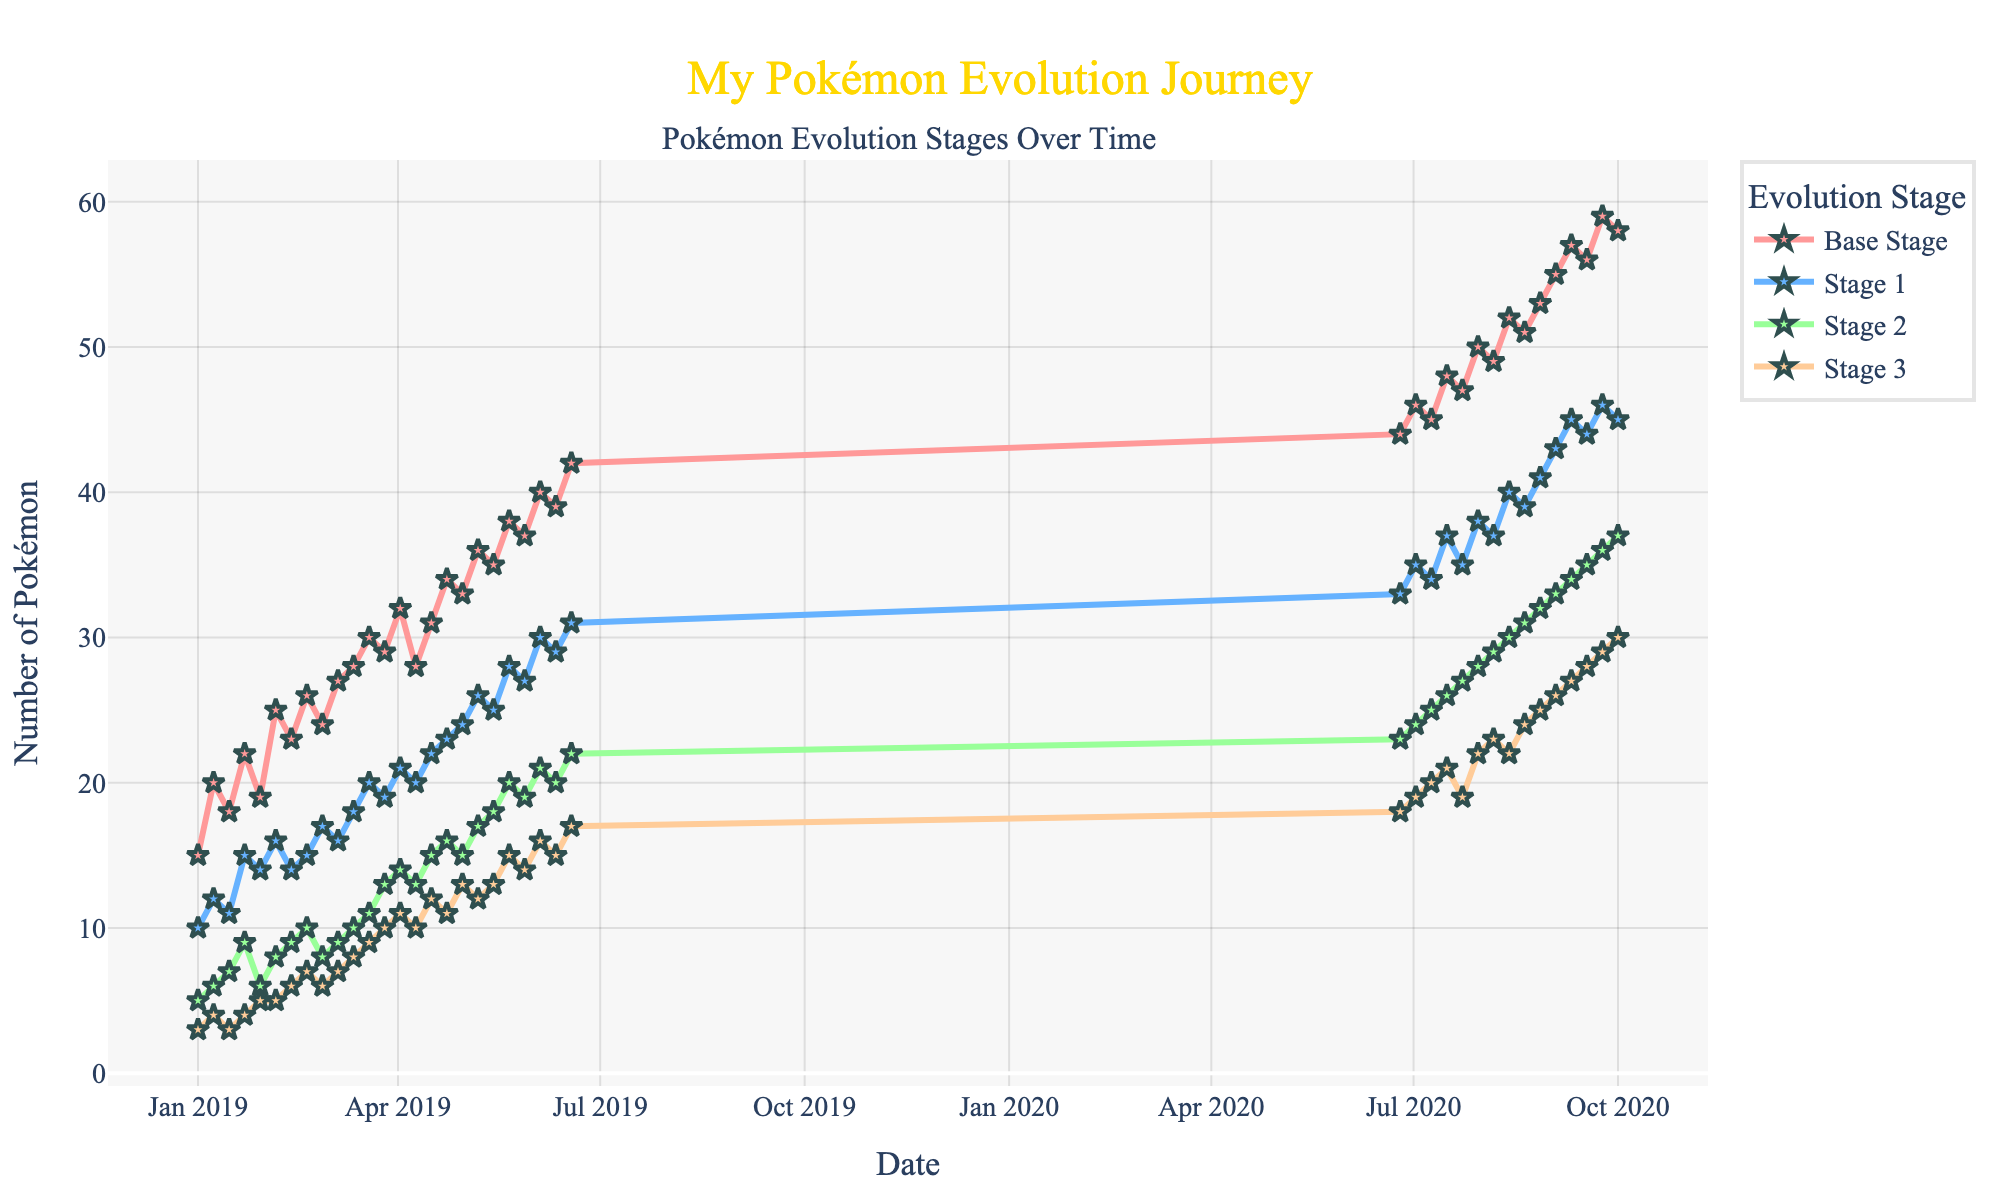What's the title of the figure? The title is located at the top of the figure and is displayed prominently in a larger font and often in a different style or color compared to other text in the figure.
Answer: My Pokémon Evolution Journey How many evolution stages are tracked in the figure? The figure uses different colored lines and markers to represent each evolution stage.
Answer: Four Which evolution stage had the highest count on July 16, 2020? The data points along the x-axis represent dates, and by locating July 16, 2020, and looking at the heights of the markers for each stage, one can determine which stage had the highest count.
Answer: Base Stage In which period did the number of Base Stage Pokémon consistently increase? By examining the line representing the Base Stage and identifying intervals where the slope is consistently upward, you can pinpoint such a period.
Answer: January to October 2020 Which evolution stage showed the smallest variation in count? Variation in count can be observed through the differences between the lowest and highest points of each line. The line with the least fluctuation indicates the smallest variation.
Answer: Stage 3 Between which dates did the count for Stage 2 Pokémon reach its peak? By following the specific line for Stage 2 and pinpointing the highest data point, we can find the corresponding dates on the x-axis.
Answer: April 2, 2019, to September 24, 2020 What was the difference in the number of Base Stage Pokémon between January 1, 2019, and February 26, 2019? Locate both dates on the x-axis, find the corresponding values for the Base Stage, and subtract the value on January 1, 2019, from the value on February 26, 2019.
Answer: 9 How does the count of Stage 1 Pokémon on September 3, 2020, compare to that on August 13, 2020? Locate the two dates on the x-axis, find the Stage 1 values, and subtract, noting if it's an increase or decrease.
Answer: 3 increase Which evolution stage showed the most significant growth from January 1, 2019, to October 1, 2020? Identify the values for each evolution stage on January 1, 2019, and October 1, 2020, calculate the differences, and compare to find the largest increase.
Answer: Base Stage Is there a period where the number of Stage 3 Pokémon decreased? Check the line representing Stage 3 for any segments that slope downward, indicating a decrease over time.
Answer: Yes, between April 16, 2019, and April 23, 2019 